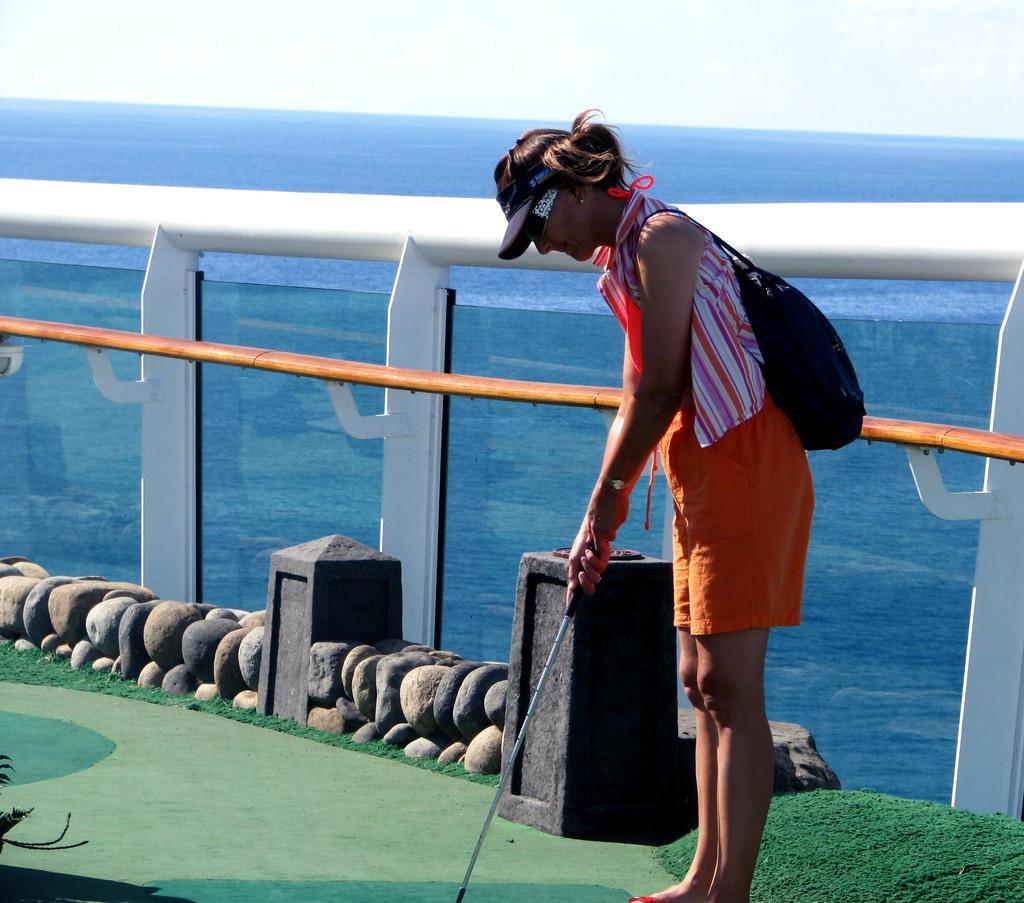In one or two sentences, can you explain what this image depicts? In this image, we can see a lady wearing a cap, a bag and holding a stick. In the background, there is a fence and we can see stones, rocks and there is water. At the top, there is sky and at the bottom, there is ground. 